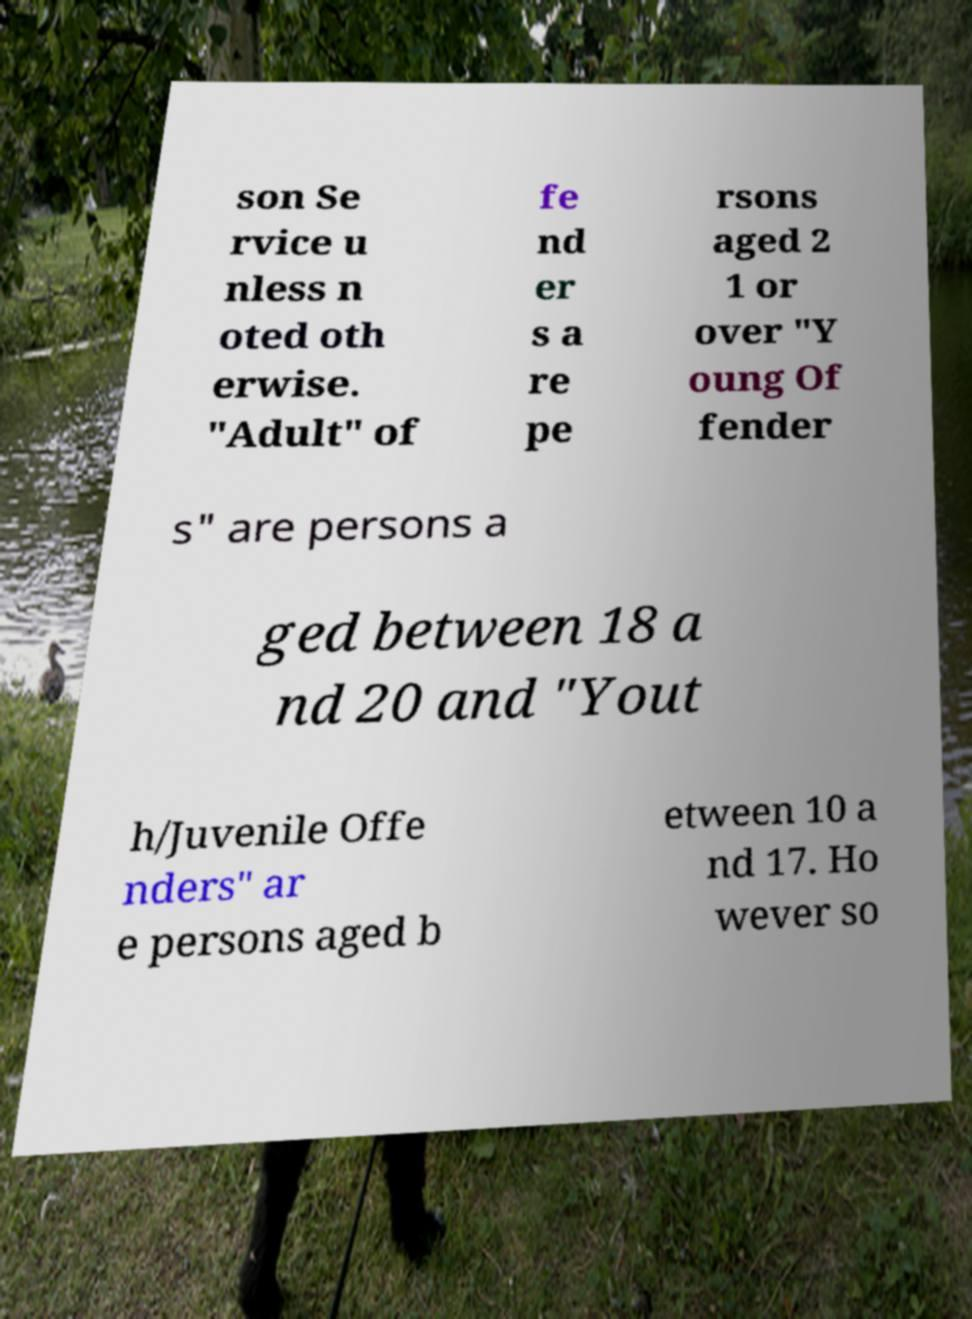For documentation purposes, I need the text within this image transcribed. Could you provide that? son Se rvice u nless n oted oth erwise. "Adult" of fe nd er s a re pe rsons aged 2 1 or over "Y oung Of fender s" are persons a ged between 18 a nd 20 and "Yout h/Juvenile Offe nders" ar e persons aged b etween 10 a nd 17. Ho wever so 